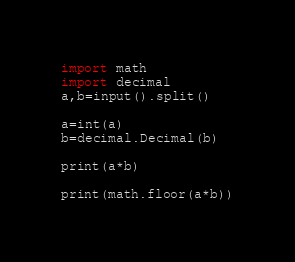<code> <loc_0><loc_0><loc_500><loc_500><_Python_>import math
import decimal
a,b=input().split()

a=int(a)
b=decimal.Decimal(b)

print(a*b)

print(math.floor(a*b))</code> 